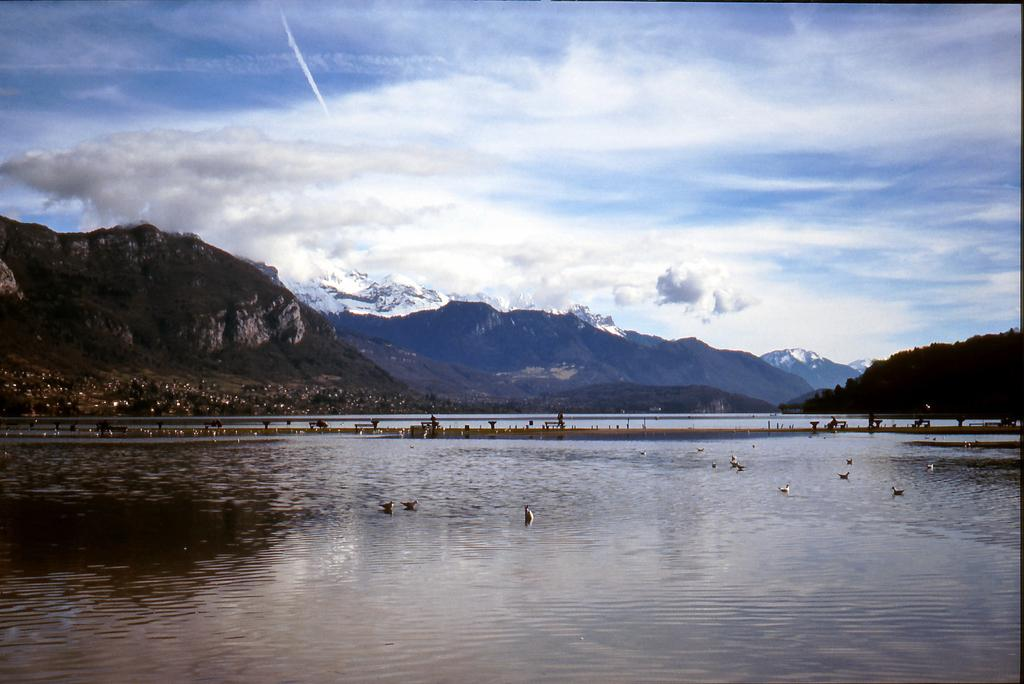What type of geographical feature can be seen in the image? There are mountains in the image. What natural element is visible in the image? There is water visible in the image. What type of vegetation is present in the image? There are trees in the image. What animals can be seen on the water surface? There are birds on the water surface. What is the color of the sky in the image? The sky is blue and white in color. How many boats are visible in the image? There are no boats present in the image. What type of verse can be heard recited by the trees in the image? There is no verse being recited by the trees in the image, as trees do not have the ability to speak or recite poetry. 